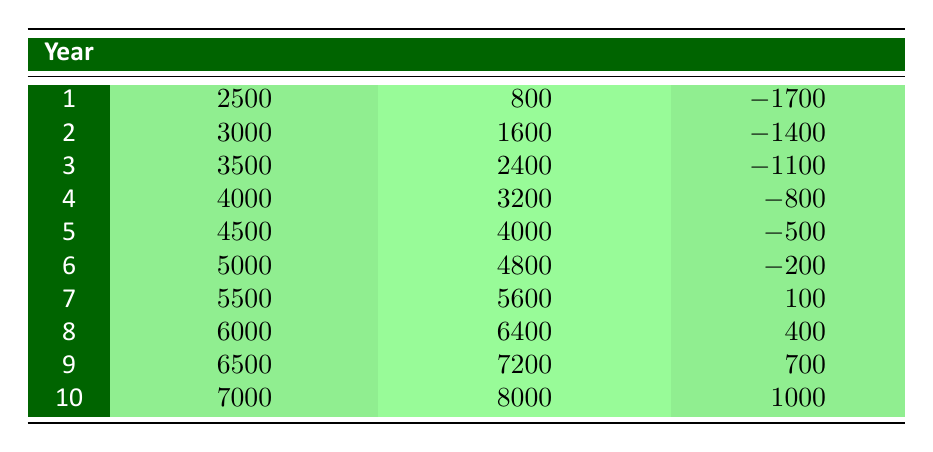What is the cumulative cost in year 5? According to the table, the cumulative cost listed for year 5 is 4500.
Answer: 4500 What is the cumulative saving in year 8? The table indicates that the cumulative saving for year 8 is 6400.
Answer: 6400 How much did the net cash flow improve from year 6 to year 7? The net cash flow for year 6 is -200 and for year 7 is 100. To find the improvement, calculate: 100 - (-200) = 300.
Answer: 300 Is the cumulative cost in year 3 greater than or equal to the cumulative savings in year 2? The cumulative cost for year 3 is 3500 and for year 2 is 1600. Since 3500 is greater than 1600, the statement is true.
Answer: Yes What is the total cumulative savings after 10 years? According to the table, the cumulative savings at year 10 is 8000, which is the total savings after the entire period.
Answer: 8000 What is the average net cash flow from year 1 to year 10? First, sum the net cash flows: (-1700) + (-1400) + (-1100) + (-800) + (-500) + (-200) + 100 + 400 + 700 + 1000 = -3500. There are 10 years, so average = -3500 / 10 = -350.
Answer: -350 For which year did the cumulative savings first exceed cumulative costs? Looking at the table, cumulative savings exceed cumulative costs first in year 7, where savings (5600) surpass costs (5500).
Answer: Year 7 What was the cumulative cash flow in year 9? In year 9, the cumulative cash flow is reported as 700.
Answer: 700 How much did cumulative costs increase from year 9 to year 10? Cumulative costs in year 9 are 6500, and in year 10 they are 7000. The increase is calculated as 7000 - 6500 = 500.
Answer: 500 